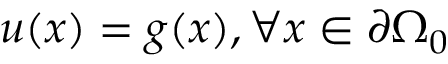Convert formula to latex. <formula><loc_0><loc_0><loc_500><loc_500>u ( x ) = g ( x ) , \forall x \in \partial \Omega _ { 0 }</formula> 